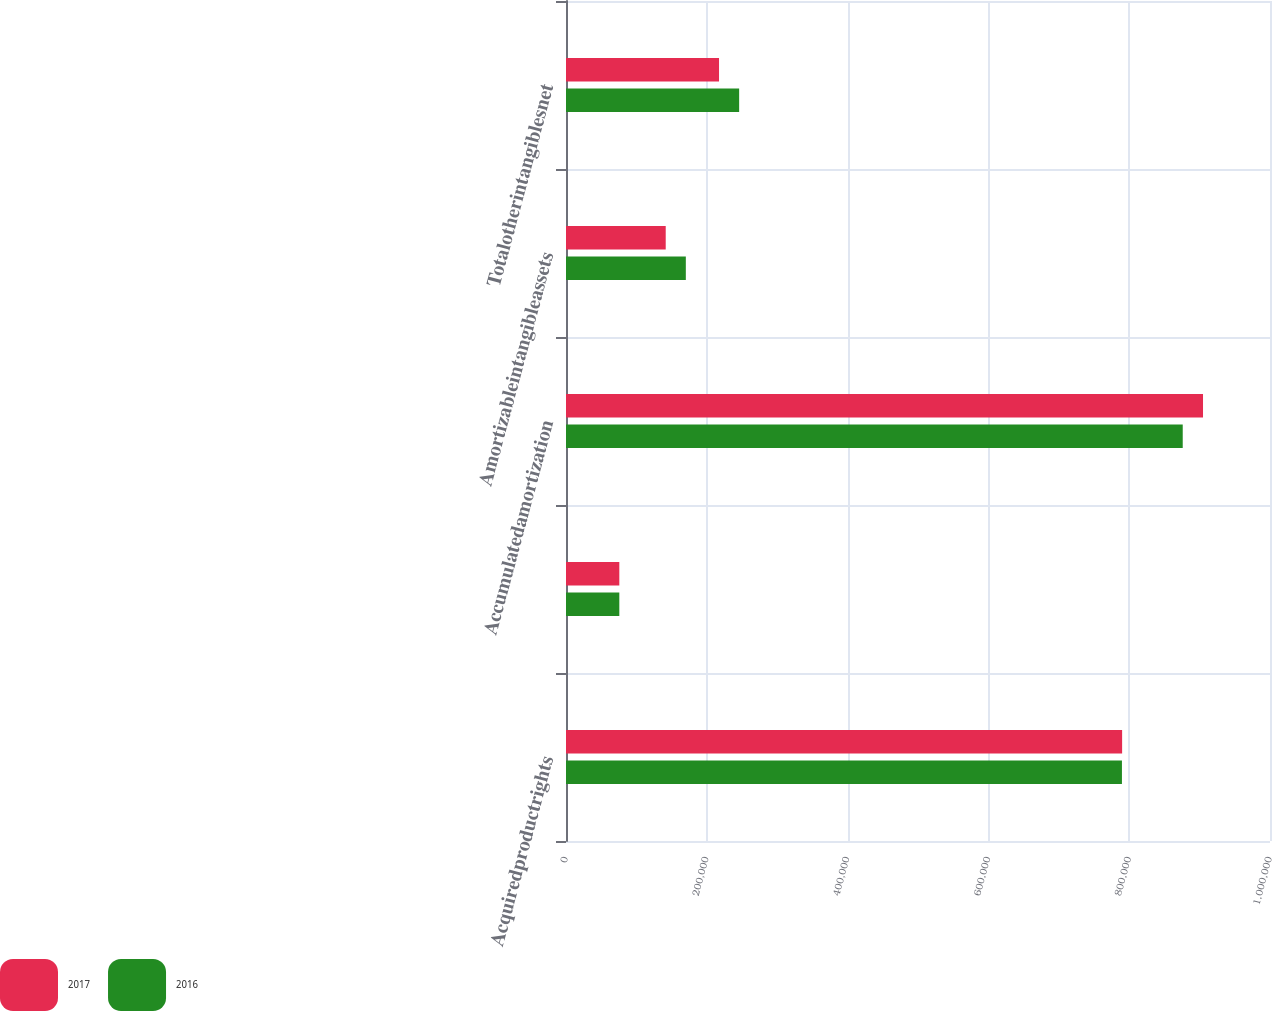Convert chart. <chart><loc_0><loc_0><loc_500><loc_500><stacked_bar_chart><ecel><fcel>Acquiredproductrights<fcel>Unnamed: 2<fcel>Accumulatedamortization<fcel>Amortizableintangibleassets<fcel>Totalotherintangiblesnet<nl><fcel>2017<fcel>789940<fcel>75738<fcel>904851<fcel>141644<fcel>217382<nl><fcel>2016<fcel>789689<fcel>75738<fcel>876033<fcel>170211<fcel>245949<nl></chart> 